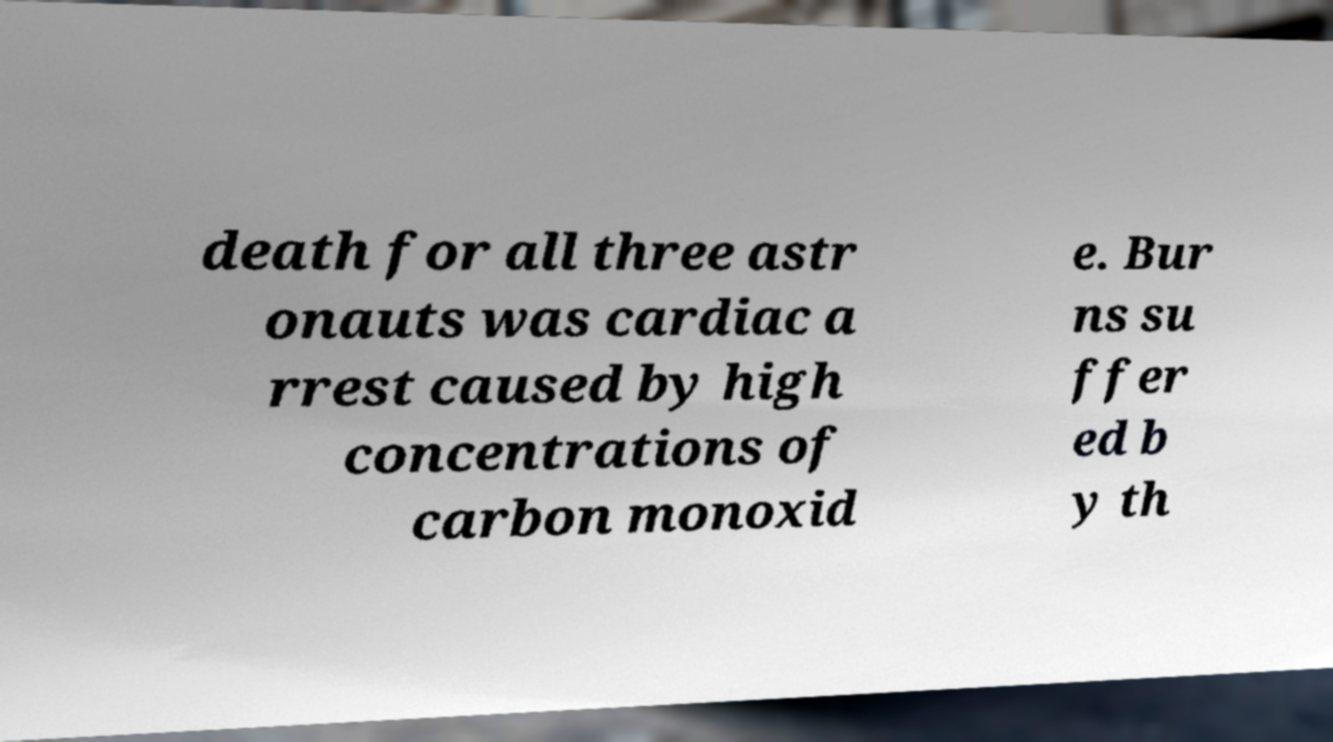I need the written content from this picture converted into text. Can you do that? death for all three astr onauts was cardiac a rrest caused by high concentrations of carbon monoxid e. Bur ns su ffer ed b y th 